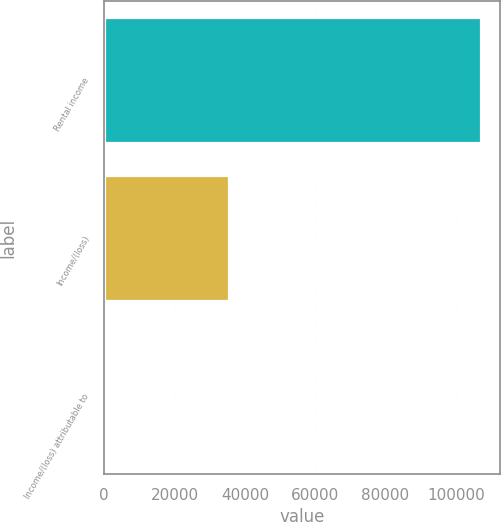<chart> <loc_0><loc_0><loc_500><loc_500><bar_chart><fcel>Rental income<fcel>Income/(loss)<fcel>Income/(loss) attributable to<nl><fcel>107266<fcel>35487.6<fcel>0.13<nl></chart> 